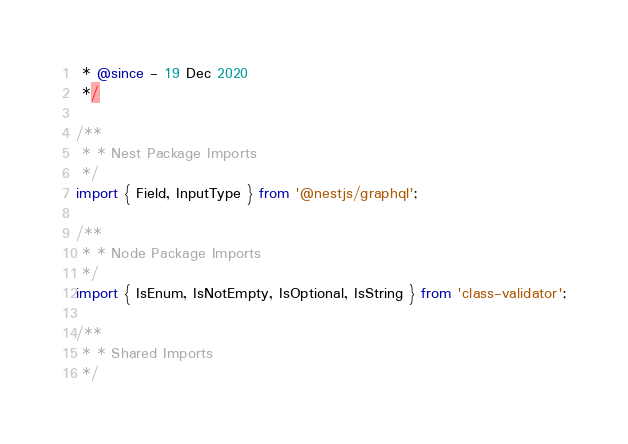<code> <loc_0><loc_0><loc_500><loc_500><_TypeScript_> * @since - 19 Dec 2020
 */

/**
 * * Nest Package Imports
 */
import { Field, InputType } from '@nestjs/graphql';

/**
 * * Node Package Imports
 */
import { IsEnum, IsNotEmpty, IsOptional, IsString } from 'class-validator';

/**
 * * Shared Imports
 */</code> 